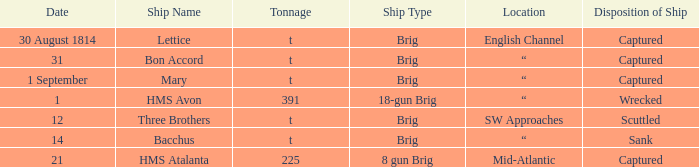With a tonnage of 225 what is the ship type? 8 gun Brig. 